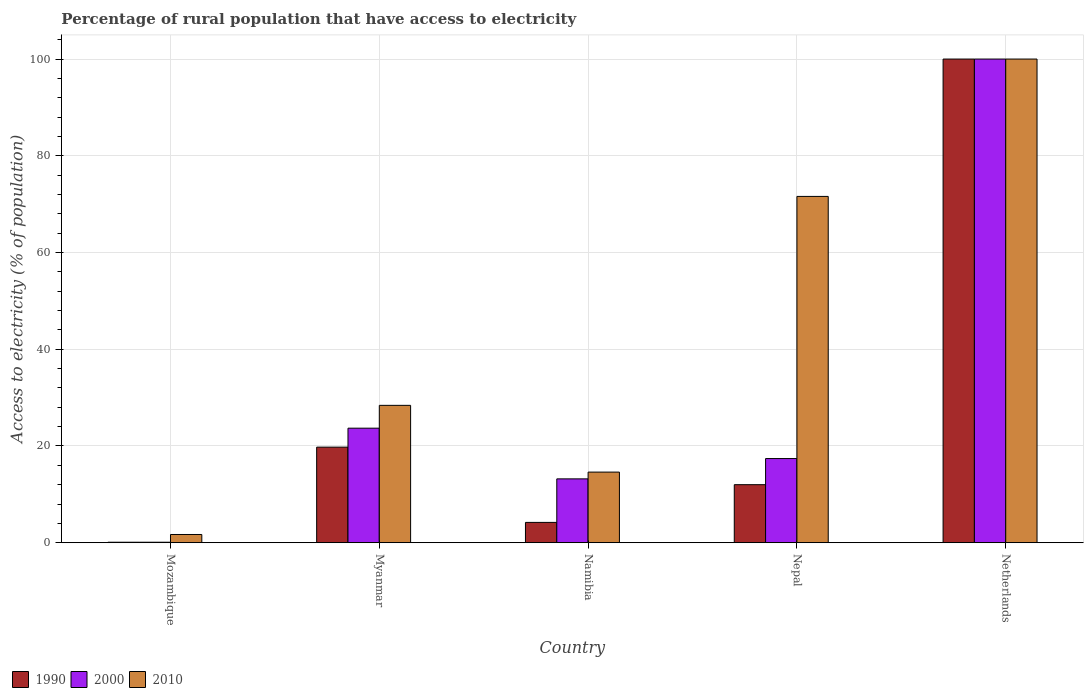How many groups of bars are there?
Provide a succinct answer. 5. What is the label of the 1st group of bars from the left?
Your answer should be very brief. Mozambique. In which country was the percentage of rural population that have access to electricity in 1990 minimum?
Offer a very short reply. Mozambique. What is the total percentage of rural population that have access to electricity in 1990 in the graph?
Make the answer very short. 136.06. What is the difference between the percentage of rural population that have access to electricity in 1990 in Mozambique and that in Nepal?
Your answer should be compact. -11.9. What is the difference between the percentage of rural population that have access to electricity in 2010 in Netherlands and the percentage of rural population that have access to electricity in 1990 in Myanmar?
Your answer should be compact. 80.24. What is the average percentage of rural population that have access to electricity in 2000 per country?
Ensure brevity in your answer.  30.88. What is the difference between the percentage of rural population that have access to electricity of/in 2010 and percentage of rural population that have access to electricity of/in 1990 in Myanmar?
Your answer should be compact. 8.64. In how many countries, is the percentage of rural population that have access to electricity in 2010 greater than 12 %?
Your answer should be very brief. 4. Is the difference between the percentage of rural population that have access to electricity in 2010 in Mozambique and Nepal greater than the difference between the percentage of rural population that have access to electricity in 1990 in Mozambique and Nepal?
Offer a very short reply. No. What is the difference between the highest and the second highest percentage of rural population that have access to electricity in 2000?
Give a very brief answer. -82.6. What is the difference between the highest and the lowest percentage of rural population that have access to electricity in 2000?
Make the answer very short. 99.9. In how many countries, is the percentage of rural population that have access to electricity in 2000 greater than the average percentage of rural population that have access to electricity in 2000 taken over all countries?
Keep it short and to the point. 1. What does the 3rd bar from the right in Namibia represents?
Offer a very short reply. 1990. How many bars are there?
Offer a very short reply. 15. How many countries are there in the graph?
Provide a short and direct response. 5. What is the difference between two consecutive major ticks on the Y-axis?
Provide a succinct answer. 20. Are the values on the major ticks of Y-axis written in scientific E-notation?
Ensure brevity in your answer.  No. Does the graph contain any zero values?
Offer a very short reply. No. How many legend labels are there?
Offer a terse response. 3. How are the legend labels stacked?
Provide a succinct answer. Horizontal. What is the title of the graph?
Offer a very short reply. Percentage of rural population that have access to electricity. What is the label or title of the Y-axis?
Offer a very short reply. Access to electricity (% of population). What is the Access to electricity (% of population) of 1990 in Mozambique?
Ensure brevity in your answer.  0.1. What is the Access to electricity (% of population) in 2010 in Mozambique?
Your response must be concise. 1.7. What is the Access to electricity (% of population) of 1990 in Myanmar?
Provide a short and direct response. 19.76. What is the Access to electricity (% of population) of 2000 in Myanmar?
Your response must be concise. 23.68. What is the Access to electricity (% of population) of 2010 in Myanmar?
Provide a succinct answer. 28.4. What is the Access to electricity (% of population) in 1990 in Namibia?
Your answer should be very brief. 4.2. What is the Access to electricity (% of population) of 2000 in Namibia?
Ensure brevity in your answer.  13.2. What is the Access to electricity (% of population) in 2010 in Namibia?
Your answer should be compact. 14.6. What is the Access to electricity (% of population) of 1990 in Nepal?
Your answer should be compact. 12. What is the Access to electricity (% of population) in 2010 in Nepal?
Give a very brief answer. 71.6. What is the Access to electricity (% of population) in 2010 in Netherlands?
Ensure brevity in your answer.  100. Across all countries, what is the minimum Access to electricity (% of population) in 1990?
Give a very brief answer. 0.1. What is the total Access to electricity (% of population) in 1990 in the graph?
Make the answer very short. 136.06. What is the total Access to electricity (% of population) in 2000 in the graph?
Your answer should be very brief. 154.38. What is the total Access to electricity (% of population) of 2010 in the graph?
Ensure brevity in your answer.  216.3. What is the difference between the Access to electricity (% of population) of 1990 in Mozambique and that in Myanmar?
Ensure brevity in your answer.  -19.66. What is the difference between the Access to electricity (% of population) of 2000 in Mozambique and that in Myanmar?
Your answer should be compact. -23.58. What is the difference between the Access to electricity (% of population) in 2010 in Mozambique and that in Myanmar?
Make the answer very short. -26.7. What is the difference between the Access to electricity (% of population) in 2010 in Mozambique and that in Namibia?
Give a very brief answer. -12.9. What is the difference between the Access to electricity (% of population) of 1990 in Mozambique and that in Nepal?
Your response must be concise. -11.9. What is the difference between the Access to electricity (% of population) in 2000 in Mozambique and that in Nepal?
Make the answer very short. -17.3. What is the difference between the Access to electricity (% of population) in 2010 in Mozambique and that in Nepal?
Provide a succinct answer. -69.9. What is the difference between the Access to electricity (% of population) of 1990 in Mozambique and that in Netherlands?
Your answer should be compact. -99.9. What is the difference between the Access to electricity (% of population) in 2000 in Mozambique and that in Netherlands?
Your response must be concise. -99.9. What is the difference between the Access to electricity (% of population) in 2010 in Mozambique and that in Netherlands?
Your answer should be compact. -98.3. What is the difference between the Access to electricity (% of population) of 1990 in Myanmar and that in Namibia?
Provide a short and direct response. 15.56. What is the difference between the Access to electricity (% of population) of 2000 in Myanmar and that in Namibia?
Offer a terse response. 10.48. What is the difference between the Access to electricity (% of population) in 1990 in Myanmar and that in Nepal?
Offer a very short reply. 7.76. What is the difference between the Access to electricity (% of population) in 2000 in Myanmar and that in Nepal?
Make the answer very short. 6.28. What is the difference between the Access to electricity (% of population) of 2010 in Myanmar and that in Nepal?
Ensure brevity in your answer.  -43.2. What is the difference between the Access to electricity (% of population) in 1990 in Myanmar and that in Netherlands?
Provide a succinct answer. -80.24. What is the difference between the Access to electricity (% of population) in 2000 in Myanmar and that in Netherlands?
Your response must be concise. -76.32. What is the difference between the Access to electricity (% of population) of 2010 in Myanmar and that in Netherlands?
Your answer should be very brief. -71.6. What is the difference between the Access to electricity (% of population) of 1990 in Namibia and that in Nepal?
Your response must be concise. -7.8. What is the difference between the Access to electricity (% of population) in 2010 in Namibia and that in Nepal?
Make the answer very short. -57. What is the difference between the Access to electricity (% of population) in 1990 in Namibia and that in Netherlands?
Give a very brief answer. -95.8. What is the difference between the Access to electricity (% of population) in 2000 in Namibia and that in Netherlands?
Offer a terse response. -86.8. What is the difference between the Access to electricity (% of population) in 2010 in Namibia and that in Netherlands?
Provide a succinct answer. -85.4. What is the difference between the Access to electricity (% of population) of 1990 in Nepal and that in Netherlands?
Offer a very short reply. -88. What is the difference between the Access to electricity (% of population) of 2000 in Nepal and that in Netherlands?
Keep it short and to the point. -82.6. What is the difference between the Access to electricity (% of population) in 2010 in Nepal and that in Netherlands?
Offer a terse response. -28.4. What is the difference between the Access to electricity (% of population) of 1990 in Mozambique and the Access to electricity (% of population) of 2000 in Myanmar?
Offer a terse response. -23.58. What is the difference between the Access to electricity (% of population) in 1990 in Mozambique and the Access to electricity (% of population) in 2010 in Myanmar?
Provide a short and direct response. -28.3. What is the difference between the Access to electricity (% of population) of 2000 in Mozambique and the Access to electricity (% of population) of 2010 in Myanmar?
Make the answer very short. -28.3. What is the difference between the Access to electricity (% of population) of 2000 in Mozambique and the Access to electricity (% of population) of 2010 in Namibia?
Provide a short and direct response. -14.5. What is the difference between the Access to electricity (% of population) in 1990 in Mozambique and the Access to electricity (% of population) in 2000 in Nepal?
Your response must be concise. -17.3. What is the difference between the Access to electricity (% of population) in 1990 in Mozambique and the Access to electricity (% of population) in 2010 in Nepal?
Give a very brief answer. -71.5. What is the difference between the Access to electricity (% of population) in 2000 in Mozambique and the Access to electricity (% of population) in 2010 in Nepal?
Your response must be concise. -71.5. What is the difference between the Access to electricity (% of population) in 1990 in Mozambique and the Access to electricity (% of population) in 2000 in Netherlands?
Ensure brevity in your answer.  -99.9. What is the difference between the Access to electricity (% of population) in 1990 in Mozambique and the Access to electricity (% of population) in 2010 in Netherlands?
Your answer should be very brief. -99.9. What is the difference between the Access to electricity (% of population) of 2000 in Mozambique and the Access to electricity (% of population) of 2010 in Netherlands?
Your response must be concise. -99.9. What is the difference between the Access to electricity (% of population) in 1990 in Myanmar and the Access to electricity (% of population) in 2000 in Namibia?
Offer a very short reply. 6.56. What is the difference between the Access to electricity (% of population) in 1990 in Myanmar and the Access to electricity (% of population) in 2010 in Namibia?
Keep it short and to the point. 5.16. What is the difference between the Access to electricity (% of population) in 2000 in Myanmar and the Access to electricity (% of population) in 2010 in Namibia?
Ensure brevity in your answer.  9.08. What is the difference between the Access to electricity (% of population) in 1990 in Myanmar and the Access to electricity (% of population) in 2000 in Nepal?
Ensure brevity in your answer.  2.36. What is the difference between the Access to electricity (% of population) in 1990 in Myanmar and the Access to electricity (% of population) in 2010 in Nepal?
Your answer should be very brief. -51.84. What is the difference between the Access to electricity (% of population) of 2000 in Myanmar and the Access to electricity (% of population) of 2010 in Nepal?
Your answer should be compact. -47.92. What is the difference between the Access to electricity (% of population) in 1990 in Myanmar and the Access to electricity (% of population) in 2000 in Netherlands?
Your answer should be very brief. -80.24. What is the difference between the Access to electricity (% of population) of 1990 in Myanmar and the Access to electricity (% of population) of 2010 in Netherlands?
Ensure brevity in your answer.  -80.24. What is the difference between the Access to electricity (% of population) in 2000 in Myanmar and the Access to electricity (% of population) in 2010 in Netherlands?
Your response must be concise. -76.32. What is the difference between the Access to electricity (% of population) of 1990 in Namibia and the Access to electricity (% of population) of 2000 in Nepal?
Offer a terse response. -13.2. What is the difference between the Access to electricity (% of population) in 1990 in Namibia and the Access to electricity (% of population) in 2010 in Nepal?
Offer a very short reply. -67.4. What is the difference between the Access to electricity (% of population) of 2000 in Namibia and the Access to electricity (% of population) of 2010 in Nepal?
Offer a very short reply. -58.4. What is the difference between the Access to electricity (% of population) in 1990 in Namibia and the Access to electricity (% of population) in 2000 in Netherlands?
Offer a very short reply. -95.8. What is the difference between the Access to electricity (% of population) in 1990 in Namibia and the Access to electricity (% of population) in 2010 in Netherlands?
Keep it short and to the point. -95.8. What is the difference between the Access to electricity (% of population) in 2000 in Namibia and the Access to electricity (% of population) in 2010 in Netherlands?
Keep it short and to the point. -86.8. What is the difference between the Access to electricity (% of population) in 1990 in Nepal and the Access to electricity (% of population) in 2000 in Netherlands?
Provide a short and direct response. -88. What is the difference between the Access to electricity (% of population) in 1990 in Nepal and the Access to electricity (% of population) in 2010 in Netherlands?
Keep it short and to the point. -88. What is the difference between the Access to electricity (% of population) of 2000 in Nepal and the Access to electricity (% of population) of 2010 in Netherlands?
Make the answer very short. -82.6. What is the average Access to electricity (% of population) in 1990 per country?
Make the answer very short. 27.21. What is the average Access to electricity (% of population) of 2000 per country?
Make the answer very short. 30.88. What is the average Access to electricity (% of population) of 2010 per country?
Your answer should be compact. 43.26. What is the difference between the Access to electricity (% of population) in 1990 and Access to electricity (% of population) in 2010 in Mozambique?
Your answer should be compact. -1.6. What is the difference between the Access to electricity (% of population) of 2000 and Access to electricity (% of population) of 2010 in Mozambique?
Offer a terse response. -1.6. What is the difference between the Access to electricity (% of population) of 1990 and Access to electricity (% of population) of 2000 in Myanmar?
Make the answer very short. -3.92. What is the difference between the Access to electricity (% of population) in 1990 and Access to electricity (% of population) in 2010 in Myanmar?
Keep it short and to the point. -8.64. What is the difference between the Access to electricity (% of population) in 2000 and Access to electricity (% of population) in 2010 in Myanmar?
Ensure brevity in your answer.  -4.72. What is the difference between the Access to electricity (% of population) in 1990 and Access to electricity (% of population) in 2000 in Namibia?
Provide a short and direct response. -9. What is the difference between the Access to electricity (% of population) in 2000 and Access to electricity (% of population) in 2010 in Namibia?
Your answer should be compact. -1.4. What is the difference between the Access to electricity (% of population) of 1990 and Access to electricity (% of population) of 2010 in Nepal?
Keep it short and to the point. -59.6. What is the difference between the Access to electricity (% of population) in 2000 and Access to electricity (% of population) in 2010 in Nepal?
Ensure brevity in your answer.  -54.2. What is the difference between the Access to electricity (% of population) in 2000 and Access to electricity (% of population) in 2010 in Netherlands?
Ensure brevity in your answer.  0. What is the ratio of the Access to electricity (% of population) of 1990 in Mozambique to that in Myanmar?
Offer a terse response. 0.01. What is the ratio of the Access to electricity (% of population) of 2000 in Mozambique to that in Myanmar?
Make the answer very short. 0. What is the ratio of the Access to electricity (% of population) of 2010 in Mozambique to that in Myanmar?
Offer a very short reply. 0.06. What is the ratio of the Access to electricity (% of population) in 1990 in Mozambique to that in Namibia?
Your answer should be very brief. 0.02. What is the ratio of the Access to electricity (% of population) of 2000 in Mozambique to that in Namibia?
Make the answer very short. 0.01. What is the ratio of the Access to electricity (% of population) of 2010 in Mozambique to that in Namibia?
Offer a terse response. 0.12. What is the ratio of the Access to electricity (% of population) in 1990 in Mozambique to that in Nepal?
Offer a terse response. 0.01. What is the ratio of the Access to electricity (% of population) in 2000 in Mozambique to that in Nepal?
Your answer should be compact. 0.01. What is the ratio of the Access to electricity (% of population) of 2010 in Mozambique to that in Nepal?
Offer a very short reply. 0.02. What is the ratio of the Access to electricity (% of population) of 1990 in Mozambique to that in Netherlands?
Offer a very short reply. 0. What is the ratio of the Access to electricity (% of population) of 2000 in Mozambique to that in Netherlands?
Make the answer very short. 0. What is the ratio of the Access to electricity (% of population) of 2010 in Mozambique to that in Netherlands?
Keep it short and to the point. 0.02. What is the ratio of the Access to electricity (% of population) in 1990 in Myanmar to that in Namibia?
Offer a terse response. 4.7. What is the ratio of the Access to electricity (% of population) of 2000 in Myanmar to that in Namibia?
Offer a terse response. 1.79. What is the ratio of the Access to electricity (% of population) of 2010 in Myanmar to that in Namibia?
Your response must be concise. 1.95. What is the ratio of the Access to electricity (% of population) of 1990 in Myanmar to that in Nepal?
Offer a very short reply. 1.65. What is the ratio of the Access to electricity (% of population) of 2000 in Myanmar to that in Nepal?
Provide a short and direct response. 1.36. What is the ratio of the Access to electricity (% of population) in 2010 in Myanmar to that in Nepal?
Provide a short and direct response. 0.4. What is the ratio of the Access to electricity (% of population) of 1990 in Myanmar to that in Netherlands?
Provide a short and direct response. 0.2. What is the ratio of the Access to electricity (% of population) of 2000 in Myanmar to that in Netherlands?
Offer a very short reply. 0.24. What is the ratio of the Access to electricity (% of population) of 2010 in Myanmar to that in Netherlands?
Give a very brief answer. 0.28. What is the ratio of the Access to electricity (% of population) in 1990 in Namibia to that in Nepal?
Provide a short and direct response. 0.35. What is the ratio of the Access to electricity (% of population) in 2000 in Namibia to that in Nepal?
Your answer should be compact. 0.76. What is the ratio of the Access to electricity (% of population) in 2010 in Namibia to that in Nepal?
Give a very brief answer. 0.2. What is the ratio of the Access to electricity (% of population) of 1990 in Namibia to that in Netherlands?
Your answer should be very brief. 0.04. What is the ratio of the Access to electricity (% of population) in 2000 in Namibia to that in Netherlands?
Make the answer very short. 0.13. What is the ratio of the Access to electricity (% of population) of 2010 in Namibia to that in Netherlands?
Offer a very short reply. 0.15. What is the ratio of the Access to electricity (% of population) of 1990 in Nepal to that in Netherlands?
Give a very brief answer. 0.12. What is the ratio of the Access to electricity (% of population) in 2000 in Nepal to that in Netherlands?
Offer a terse response. 0.17. What is the ratio of the Access to electricity (% of population) of 2010 in Nepal to that in Netherlands?
Keep it short and to the point. 0.72. What is the difference between the highest and the second highest Access to electricity (% of population) of 1990?
Ensure brevity in your answer.  80.24. What is the difference between the highest and the second highest Access to electricity (% of population) in 2000?
Give a very brief answer. 76.32. What is the difference between the highest and the second highest Access to electricity (% of population) of 2010?
Give a very brief answer. 28.4. What is the difference between the highest and the lowest Access to electricity (% of population) in 1990?
Your response must be concise. 99.9. What is the difference between the highest and the lowest Access to electricity (% of population) in 2000?
Your answer should be very brief. 99.9. What is the difference between the highest and the lowest Access to electricity (% of population) of 2010?
Provide a succinct answer. 98.3. 